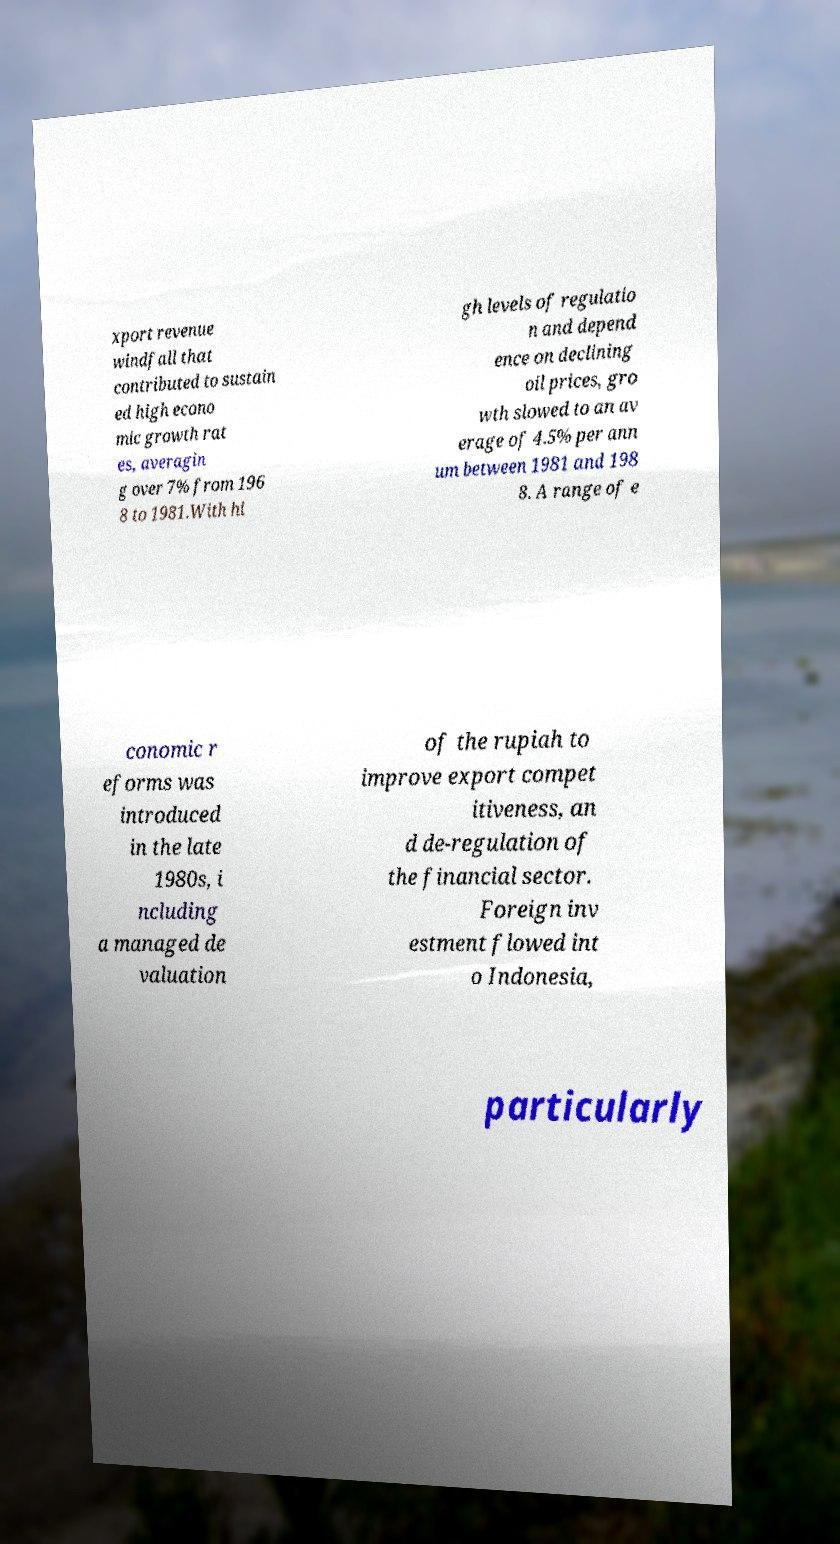Could you extract and type out the text from this image? xport revenue windfall that contributed to sustain ed high econo mic growth rat es, averagin g over 7% from 196 8 to 1981.With hi gh levels of regulatio n and depend ence on declining oil prices, gro wth slowed to an av erage of 4.5% per ann um between 1981 and 198 8. A range of e conomic r eforms was introduced in the late 1980s, i ncluding a managed de valuation of the rupiah to improve export compet itiveness, an d de-regulation of the financial sector. Foreign inv estment flowed int o Indonesia, particularly 